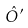Convert formula to latex. <formula><loc_0><loc_0><loc_500><loc_500>\hat { O } ^ { \prime }</formula> 